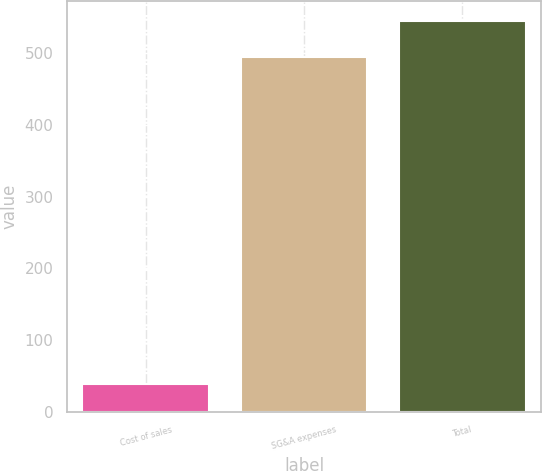Convert chart. <chart><loc_0><loc_0><loc_500><loc_500><bar_chart><fcel>Cost of sales<fcel>SG&A expenses<fcel>Total<nl><fcel>39<fcel>495<fcel>545.3<nl></chart> 